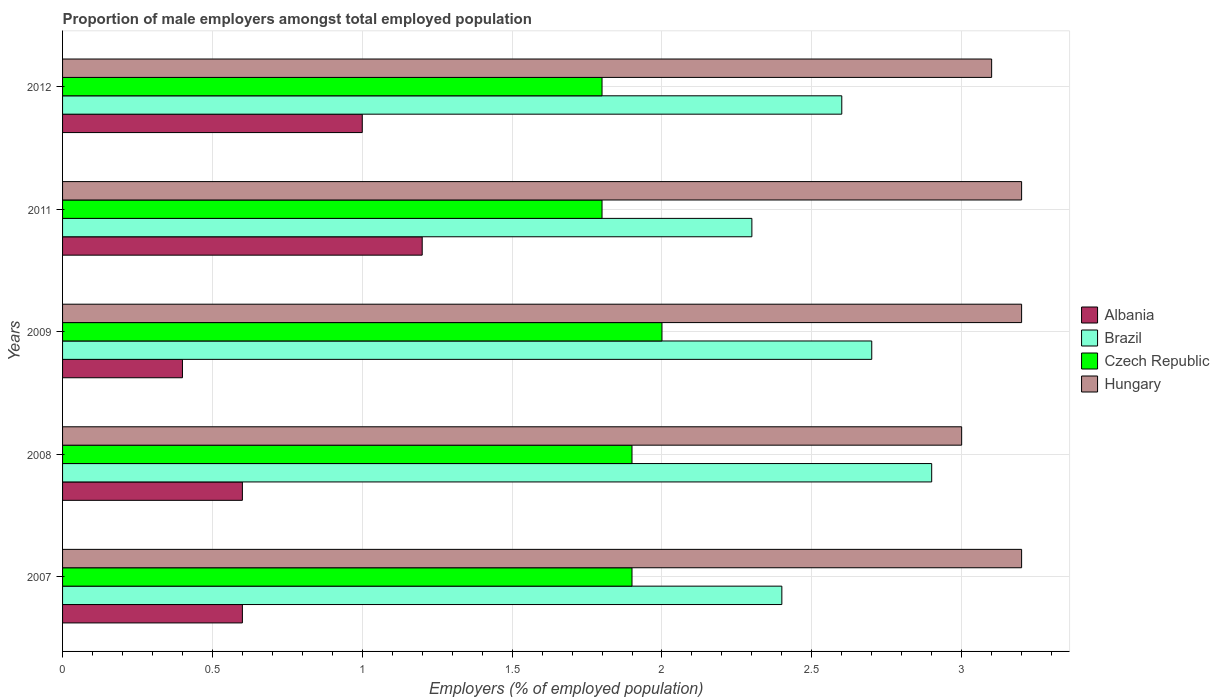How many different coloured bars are there?
Your answer should be very brief. 4. Are the number of bars per tick equal to the number of legend labels?
Keep it short and to the point. Yes. Are the number of bars on each tick of the Y-axis equal?
Make the answer very short. Yes. How many bars are there on the 2nd tick from the bottom?
Offer a very short reply. 4. What is the label of the 2nd group of bars from the top?
Your answer should be compact. 2011. What is the proportion of male employers in Brazil in 2009?
Give a very brief answer. 2.7. Across all years, what is the maximum proportion of male employers in Brazil?
Ensure brevity in your answer.  2.9. Across all years, what is the minimum proportion of male employers in Hungary?
Your response must be concise. 3. In which year was the proportion of male employers in Brazil maximum?
Provide a short and direct response. 2008. What is the total proportion of male employers in Hungary in the graph?
Provide a succinct answer. 15.7. What is the difference between the proportion of male employers in Brazil in 2009 and the proportion of male employers in Czech Republic in 2007?
Offer a very short reply. 0.8. What is the average proportion of male employers in Brazil per year?
Provide a succinct answer. 2.58. In the year 2008, what is the difference between the proportion of male employers in Czech Republic and proportion of male employers in Albania?
Keep it short and to the point. 1.3. What is the ratio of the proportion of male employers in Hungary in 2008 to that in 2012?
Your answer should be compact. 0.97. Is the proportion of male employers in Czech Republic in 2008 less than that in 2011?
Give a very brief answer. No. What is the difference between the highest and the second highest proportion of male employers in Brazil?
Give a very brief answer. 0.2. What is the difference between the highest and the lowest proportion of male employers in Czech Republic?
Keep it short and to the point. 0.2. What does the 4th bar from the top in 2009 represents?
Offer a terse response. Albania. What does the 4th bar from the bottom in 2011 represents?
Keep it short and to the point. Hungary. Is it the case that in every year, the sum of the proportion of male employers in Hungary and proportion of male employers in Czech Republic is greater than the proportion of male employers in Brazil?
Provide a succinct answer. Yes. How many bars are there?
Your answer should be very brief. 20. How many years are there in the graph?
Your answer should be very brief. 5. Are the values on the major ticks of X-axis written in scientific E-notation?
Your answer should be compact. No. Does the graph contain any zero values?
Keep it short and to the point. No. How many legend labels are there?
Your response must be concise. 4. What is the title of the graph?
Ensure brevity in your answer.  Proportion of male employers amongst total employed population. What is the label or title of the X-axis?
Your answer should be compact. Employers (% of employed population). What is the label or title of the Y-axis?
Your answer should be very brief. Years. What is the Employers (% of employed population) of Albania in 2007?
Your answer should be compact. 0.6. What is the Employers (% of employed population) of Brazil in 2007?
Keep it short and to the point. 2.4. What is the Employers (% of employed population) in Czech Republic in 2007?
Your answer should be compact. 1.9. What is the Employers (% of employed population) of Hungary in 2007?
Offer a terse response. 3.2. What is the Employers (% of employed population) of Albania in 2008?
Your answer should be compact. 0.6. What is the Employers (% of employed population) in Brazil in 2008?
Ensure brevity in your answer.  2.9. What is the Employers (% of employed population) of Czech Republic in 2008?
Provide a succinct answer. 1.9. What is the Employers (% of employed population) in Hungary in 2008?
Your response must be concise. 3. What is the Employers (% of employed population) in Albania in 2009?
Your response must be concise. 0.4. What is the Employers (% of employed population) in Brazil in 2009?
Your answer should be very brief. 2.7. What is the Employers (% of employed population) in Hungary in 2009?
Your response must be concise. 3.2. What is the Employers (% of employed population) of Albania in 2011?
Your response must be concise. 1.2. What is the Employers (% of employed population) of Brazil in 2011?
Keep it short and to the point. 2.3. What is the Employers (% of employed population) in Czech Republic in 2011?
Your response must be concise. 1.8. What is the Employers (% of employed population) of Hungary in 2011?
Provide a succinct answer. 3.2. What is the Employers (% of employed population) of Brazil in 2012?
Offer a terse response. 2.6. What is the Employers (% of employed population) of Czech Republic in 2012?
Offer a very short reply. 1.8. What is the Employers (% of employed population) in Hungary in 2012?
Your answer should be compact. 3.1. Across all years, what is the maximum Employers (% of employed population) in Albania?
Ensure brevity in your answer.  1.2. Across all years, what is the maximum Employers (% of employed population) of Brazil?
Your answer should be compact. 2.9. Across all years, what is the maximum Employers (% of employed population) of Hungary?
Offer a terse response. 3.2. Across all years, what is the minimum Employers (% of employed population) in Albania?
Your answer should be very brief. 0.4. Across all years, what is the minimum Employers (% of employed population) of Brazil?
Offer a terse response. 2.3. Across all years, what is the minimum Employers (% of employed population) in Czech Republic?
Keep it short and to the point. 1.8. What is the total Employers (% of employed population) of Albania in the graph?
Give a very brief answer. 3.8. What is the total Employers (% of employed population) of Brazil in the graph?
Give a very brief answer. 12.9. What is the total Employers (% of employed population) in Hungary in the graph?
Ensure brevity in your answer.  15.7. What is the difference between the Employers (% of employed population) in Albania in 2007 and that in 2008?
Give a very brief answer. 0. What is the difference between the Employers (% of employed population) in Brazil in 2007 and that in 2008?
Offer a very short reply. -0.5. What is the difference between the Employers (% of employed population) of Czech Republic in 2007 and that in 2008?
Offer a terse response. 0. What is the difference between the Employers (% of employed population) in Hungary in 2007 and that in 2008?
Your answer should be very brief. 0.2. What is the difference between the Employers (% of employed population) of Brazil in 2007 and that in 2009?
Give a very brief answer. -0.3. What is the difference between the Employers (% of employed population) in Czech Republic in 2007 and that in 2009?
Give a very brief answer. -0.1. What is the difference between the Employers (% of employed population) in Brazil in 2007 and that in 2011?
Provide a succinct answer. 0.1. What is the difference between the Employers (% of employed population) in Czech Republic in 2007 and that in 2011?
Provide a succinct answer. 0.1. What is the difference between the Employers (% of employed population) in Hungary in 2007 and that in 2011?
Your response must be concise. 0. What is the difference between the Employers (% of employed population) in Brazil in 2007 and that in 2012?
Provide a succinct answer. -0.2. What is the difference between the Employers (% of employed population) in Hungary in 2007 and that in 2012?
Your answer should be very brief. 0.1. What is the difference between the Employers (% of employed population) in Brazil in 2008 and that in 2009?
Offer a very short reply. 0.2. What is the difference between the Employers (% of employed population) in Brazil in 2008 and that in 2011?
Your response must be concise. 0.6. What is the difference between the Employers (% of employed population) in Czech Republic in 2008 and that in 2011?
Offer a terse response. 0.1. What is the difference between the Employers (% of employed population) of Brazil in 2008 and that in 2012?
Provide a short and direct response. 0.3. What is the difference between the Employers (% of employed population) of Czech Republic in 2008 and that in 2012?
Your answer should be very brief. 0.1. What is the difference between the Employers (% of employed population) of Albania in 2009 and that in 2011?
Your answer should be compact. -0.8. What is the difference between the Employers (% of employed population) in Brazil in 2009 and that in 2011?
Give a very brief answer. 0.4. What is the difference between the Employers (% of employed population) in Czech Republic in 2009 and that in 2011?
Provide a succinct answer. 0.2. What is the difference between the Employers (% of employed population) of Albania in 2009 and that in 2012?
Your answer should be very brief. -0.6. What is the difference between the Employers (% of employed population) of Czech Republic in 2009 and that in 2012?
Offer a terse response. 0.2. What is the difference between the Employers (% of employed population) of Hungary in 2009 and that in 2012?
Keep it short and to the point. 0.1. What is the difference between the Employers (% of employed population) in Albania in 2011 and that in 2012?
Offer a terse response. 0.2. What is the difference between the Employers (% of employed population) of Hungary in 2011 and that in 2012?
Provide a short and direct response. 0.1. What is the difference between the Employers (% of employed population) in Brazil in 2007 and the Employers (% of employed population) in Hungary in 2008?
Your response must be concise. -0.6. What is the difference between the Employers (% of employed population) of Albania in 2007 and the Employers (% of employed population) of Czech Republic in 2011?
Your response must be concise. -1.2. What is the difference between the Employers (% of employed population) in Albania in 2007 and the Employers (% of employed population) in Hungary in 2011?
Keep it short and to the point. -2.6. What is the difference between the Employers (% of employed population) in Brazil in 2007 and the Employers (% of employed population) in Hungary in 2011?
Keep it short and to the point. -0.8. What is the difference between the Employers (% of employed population) of Czech Republic in 2007 and the Employers (% of employed population) of Hungary in 2011?
Your answer should be compact. -1.3. What is the difference between the Employers (% of employed population) of Albania in 2007 and the Employers (% of employed population) of Brazil in 2012?
Provide a short and direct response. -2. What is the difference between the Employers (% of employed population) in Brazil in 2007 and the Employers (% of employed population) in Czech Republic in 2012?
Give a very brief answer. 0.6. What is the difference between the Employers (% of employed population) of Brazil in 2007 and the Employers (% of employed population) of Hungary in 2012?
Keep it short and to the point. -0.7. What is the difference between the Employers (% of employed population) of Albania in 2008 and the Employers (% of employed population) of Czech Republic in 2009?
Ensure brevity in your answer.  -1.4. What is the difference between the Employers (% of employed population) in Albania in 2008 and the Employers (% of employed population) in Hungary in 2009?
Make the answer very short. -2.6. What is the difference between the Employers (% of employed population) in Brazil in 2008 and the Employers (% of employed population) in Czech Republic in 2009?
Your answer should be compact. 0.9. What is the difference between the Employers (% of employed population) in Albania in 2008 and the Employers (% of employed population) in Czech Republic in 2011?
Provide a short and direct response. -1.2. What is the difference between the Employers (% of employed population) of Albania in 2008 and the Employers (% of employed population) of Hungary in 2011?
Your answer should be very brief. -2.6. What is the difference between the Employers (% of employed population) in Brazil in 2008 and the Employers (% of employed population) in Czech Republic in 2011?
Your answer should be compact. 1.1. What is the difference between the Employers (% of employed population) of Albania in 2008 and the Employers (% of employed population) of Hungary in 2012?
Keep it short and to the point. -2.5. What is the difference between the Employers (% of employed population) in Brazil in 2008 and the Employers (% of employed population) in Czech Republic in 2012?
Ensure brevity in your answer.  1.1. What is the difference between the Employers (% of employed population) in Brazil in 2008 and the Employers (% of employed population) in Hungary in 2012?
Your answer should be very brief. -0.2. What is the difference between the Employers (% of employed population) in Albania in 2009 and the Employers (% of employed population) in Czech Republic in 2011?
Offer a very short reply. -1.4. What is the difference between the Employers (% of employed population) of Brazil in 2009 and the Employers (% of employed population) of Czech Republic in 2011?
Offer a very short reply. 0.9. What is the difference between the Employers (% of employed population) of Brazil in 2009 and the Employers (% of employed population) of Hungary in 2011?
Offer a very short reply. -0.5. What is the difference between the Employers (% of employed population) of Albania in 2009 and the Employers (% of employed population) of Brazil in 2012?
Provide a succinct answer. -2.2. What is the difference between the Employers (% of employed population) in Albania in 2009 and the Employers (% of employed population) in Hungary in 2012?
Provide a short and direct response. -2.7. What is the difference between the Employers (% of employed population) in Brazil in 2009 and the Employers (% of employed population) in Czech Republic in 2012?
Offer a terse response. 0.9. What is the difference between the Employers (% of employed population) of Brazil in 2009 and the Employers (% of employed population) of Hungary in 2012?
Ensure brevity in your answer.  -0.4. What is the difference between the Employers (% of employed population) in Albania in 2011 and the Employers (% of employed population) in Brazil in 2012?
Offer a very short reply. -1.4. What is the difference between the Employers (% of employed population) in Albania in 2011 and the Employers (% of employed population) in Czech Republic in 2012?
Give a very brief answer. -0.6. What is the difference between the Employers (% of employed population) in Albania in 2011 and the Employers (% of employed population) in Hungary in 2012?
Ensure brevity in your answer.  -1.9. What is the difference between the Employers (% of employed population) of Czech Republic in 2011 and the Employers (% of employed population) of Hungary in 2012?
Provide a short and direct response. -1.3. What is the average Employers (% of employed population) in Albania per year?
Give a very brief answer. 0.76. What is the average Employers (% of employed population) in Brazil per year?
Provide a short and direct response. 2.58. What is the average Employers (% of employed population) of Czech Republic per year?
Make the answer very short. 1.88. What is the average Employers (% of employed population) in Hungary per year?
Offer a very short reply. 3.14. In the year 2007, what is the difference between the Employers (% of employed population) of Albania and Employers (% of employed population) of Czech Republic?
Make the answer very short. -1.3. In the year 2007, what is the difference between the Employers (% of employed population) of Albania and Employers (% of employed population) of Hungary?
Offer a terse response. -2.6. In the year 2007, what is the difference between the Employers (% of employed population) in Brazil and Employers (% of employed population) in Hungary?
Your answer should be compact. -0.8. In the year 2008, what is the difference between the Employers (% of employed population) of Albania and Employers (% of employed population) of Czech Republic?
Keep it short and to the point. -1.3. In the year 2008, what is the difference between the Employers (% of employed population) of Brazil and Employers (% of employed population) of Czech Republic?
Offer a terse response. 1. In the year 2008, what is the difference between the Employers (% of employed population) of Brazil and Employers (% of employed population) of Hungary?
Make the answer very short. -0.1. In the year 2008, what is the difference between the Employers (% of employed population) in Czech Republic and Employers (% of employed population) in Hungary?
Keep it short and to the point. -1.1. In the year 2009, what is the difference between the Employers (% of employed population) in Albania and Employers (% of employed population) in Hungary?
Provide a short and direct response. -2.8. In the year 2009, what is the difference between the Employers (% of employed population) of Brazil and Employers (% of employed population) of Czech Republic?
Your response must be concise. 0.7. In the year 2011, what is the difference between the Employers (% of employed population) of Albania and Employers (% of employed population) of Brazil?
Your response must be concise. -1.1. In the year 2011, what is the difference between the Employers (% of employed population) of Czech Republic and Employers (% of employed population) of Hungary?
Offer a very short reply. -1.4. In the year 2012, what is the difference between the Employers (% of employed population) in Albania and Employers (% of employed population) in Czech Republic?
Provide a succinct answer. -0.8. In the year 2012, what is the difference between the Employers (% of employed population) in Albania and Employers (% of employed population) in Hungary?
Your response must be concise. -2.1. In the year 2012, what is the difference between the Employers (% of employed population) in Czech Republic and Employers (% of employed population) in Hungary?
Make the answer very short. -1.3. What is the ratio of the Employers (% of employed population) in Albania in 2007 to that in 2008?
Ensure brevity in your answer.  1. What is the ratio of the Employers (% of employed population) of Brazil in 2007 to that in 2008?
Your answer should be very brief. 0.83. What is the ratio of the Employers (% of employed population) in Czech Republic in 2007 to that in 2008?
Provide a short and direct response. 1. What is the ratio of the Employers (% of employed population) in Hungary in 2007 to that in 2008?
Your answer should be very brief. 1.07. What is the ratio of the Employers (% of employed population) in Albania in 2007 to that in 2009?
Provide a short and direct response. 1.5. What is the ratio of the Employers (% of employed population) in Albania in 2007 to that in 2011?
Your response must be concise. 0.5. What is the ratio of the Employers (% of employed population) in Brazil in 2007 to that in 2011?
Offer a terse response. 1.04. What is the ratio of the Employers (% of employed population) of Czech Republic in 2007 to that in 2011?
Your answer should be very brief. 1.06. What is the ratio of the Employers (% of employed population) in Albania in 2007 to that in 2012?
Give a very brief answer. 0.6. What is the ratio of the Employers (% of employed population) of Brazil in 2007 to that in 2012?
Offer a very short reply. 0.92. What is the ratio of the Employers (% of employed population) of Czech Republic in 2007 to that in 2012?
Your answer should be compact. 1.06. What is the ratio of the Employers (% of employed population) in Hungary in 2007 to that in 2012?
Keep it short and to the point. 1.03. What is the ratio of the Employers (% of employed population) in Brazil in 2008 to that in 2009?
Keep it short and to the point. 1.07. What is the ratio of the Employers (% of employed population) in Czech Republic in 2008 to that in 2009?
Your answer should be compact. 0.95. What is the ratio of the Employers (% of employed population) in Brazil in 2008 to that in 2011?
Give a very brief answer. 1.26. What is the ratio of the Employers (% of employed population) in Czech Republic in 2008 to that in 2011?
Give a very brief answer. 1.06. What is the ratio of the Employers (% of employed population) of Hungary in 2008 to that in 2011?
Provide a short and direct response. 0.94. What is the ratio of the Employers (% of employed population) in Albania in 2008 to that in 2012?
Give a very brief answer. 0.6. What is the ratio of the Employers (% of employed population) of Brazil in 2008 to that in 2012?
Provide a succinct answer. 1.12. What is the ratio of the Employers (% of employed population) of Czech Republic in 2008 to that in 2012?
Give a very brief answer. 1.06. What is the ratio of the Employers (% of employed population) of Hungary in 2008 to that in 2012?
Your answer should be compact. 0.97. What is the ratio of the Employers (% of employed population) in Brazil in 2009 to that in 2011?
Offer a terse response. 1.17. What is the ratio of the Employers (% of employed population) in Hungary in 2009 to that in 2011?
Keep it short and to the point. 1. What is the ratio of the Employers (% of employed population) of Czech Republic in 2009 to that in 2012?
Your response must be concise. 1.11. What is the ratio of the Employers (% of employed population) of Hungary in 2009 to that in 2012?
Make the answer very short. 1.03. What is the ratio of the Employers (% of employed population) in Brazil in 2011 to that in 2012?
Keep it short and to the point. 0.88. What is the ratio of the Employers (% of employed population) of Czech Republic in 2011 to that in 2012?
Ensure brevity in your answer.  1. What is the ratio of the Employers (% of employed population) in Hungary in 2011 to that in 2012?
Your answer should be compact. 1.03. What is the difference between the highest and the second highest Employers (% of employed population) of Hungary?
Ensure brevity in your answer.  0. What is the difference between the highest and the lowest Employers (% of employed population) of Albania?
Ensure brevity in your answer.  0.8. What is the difference between the highest and the lowest Employers (% of employed population) in Hungary?
Your response must be concise. 0.2. 